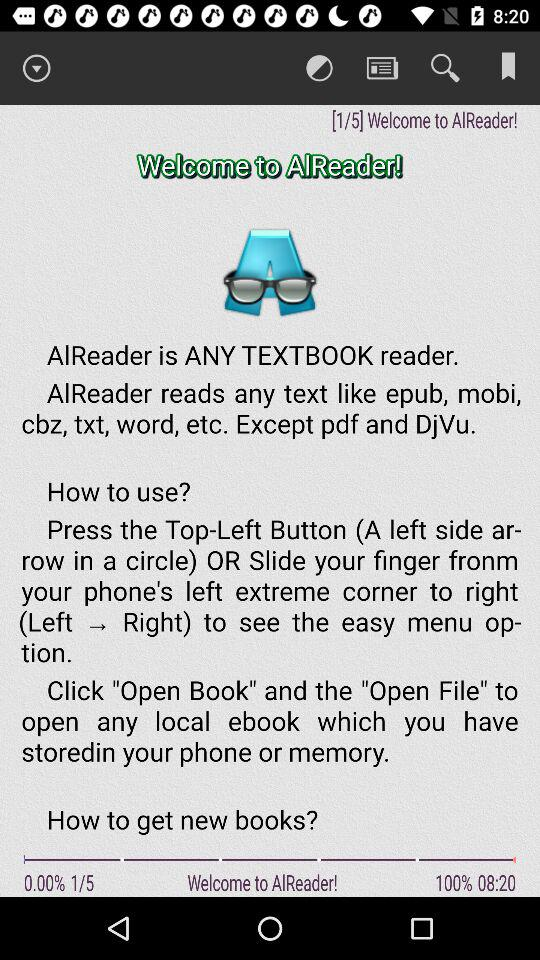What is the name of the application? The name of the application is "AlReader". 